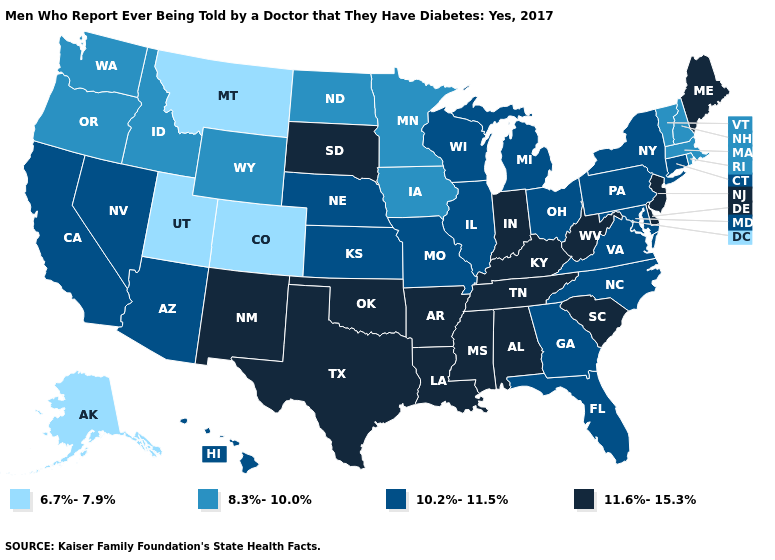What is the value of Connecticut?
Answer briefly. 10.2%-11.5%. Name the states that have a value in the range 6.7%-7.9%?
Short answer required. Alaska, Colorado, Montana, Utah. Name the states that have a value in the range 8.3%-10.0%?
Write a very short answer. Idaho, Iowa, Massachusetts, Minnesota, New Hampshire, North Dakota, Oregon, Rhode Island, Vermont, Washington, Wyoming. What is the lowest value in states that border Massachusetts?
Be succinct. 8.3%-10.0%. Which states have the lowest value in the Northeast?
Be succinct. Massachusetts, New Hampshire, Rhode Island, Vermont. How many symbols are there in the legend?
Write a very short answer. 4. What is the highest value in the Northeast ?
Give a very brief answer. 11.6%-15.3%. Name the states that have a value in the range 6.7%-7.9%?
Be succinct. Alaska, Colorado, Montana, Utah. What is the value of Wyoming?
Be succinct. 8.3%-10.0%. What is the value of South Carolina?
Be succinct. 11.6%-15.3%. Which states have the highest value in the USA?
Quick response, please. Alabama, Arkansas, Delaware, Indiana, Kentucky, Louisiana, Maine, Mississippi, New Jersey, New Mexico, Oklahoma, South Carolina, South Dakota, Tennessee, Texas, West Virginia. Does Washington have a lower value than Idaho?
Give a very brief answer. No. What is the value of West Virginia?
Concise answer only. 11.6%-15.3%. Among the states that border Nebraska , does Missouri have the lowest value?
Be succinct. No. Does Illinois have the lowest value in the USA?
Answer briefly. No. 